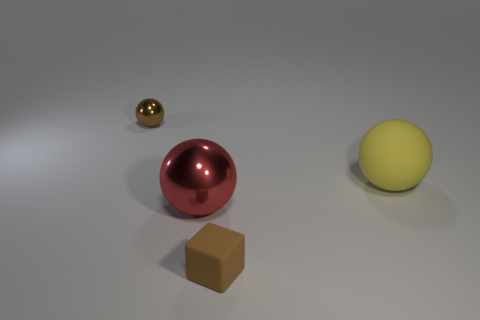Add 4 red things. How many objects exist? 8 Subtract all spheres. How many objects are left? 1 Subtract all big yellow things. Subtract all yellow matte things. How many objects are left? 2 Add 2 large red objects. How many large red objects are left? 3 Add 4 big blue things. How many big blue things exist? 4 Subtract 0 red blocks. How many objects are left? 4 